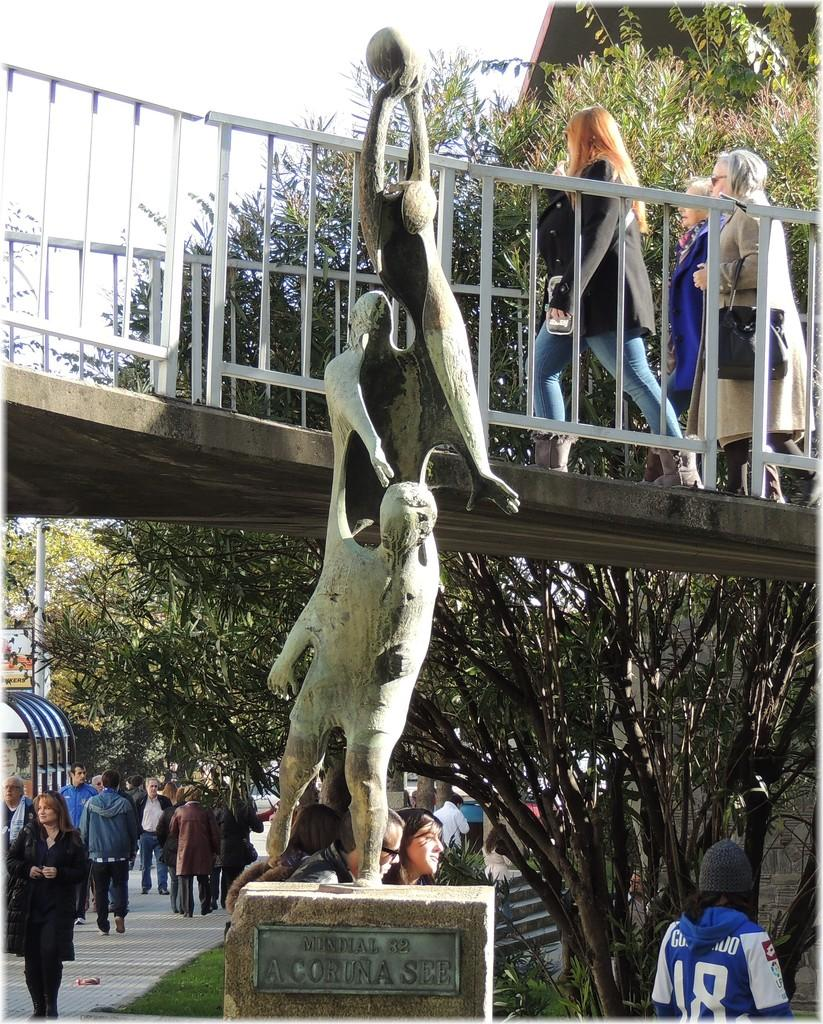Provide a one-sentence caption for the provided image. A statue is identified with a Mundial 82 sign. 